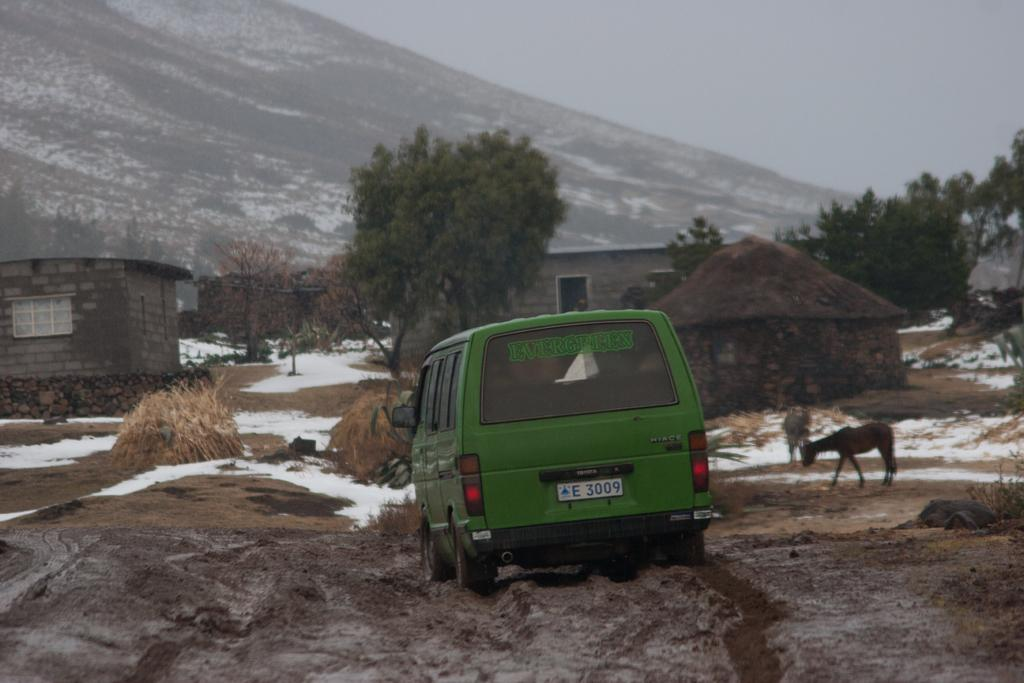What type of vehicle is in the image? There is a van in the image. What color is the van? The van is green. What is visible at the bottom of the image? There is ground visible at the bottom of the image. What can be seen in the background of the image? There are trees, small huts, and a mountain in the background of the image. What type of food is being served at the club in the image? There is no club or food present in the image; it features a green van and a background with trees, small huts, and a mountain. 